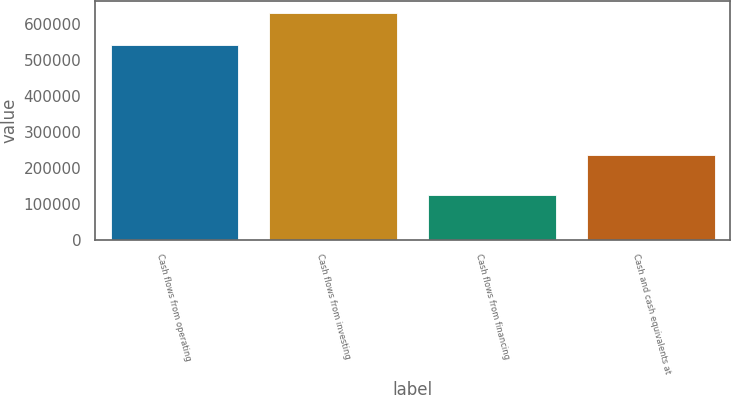Convert chart. <chart><loc_0><loc_0><loc_500><loc_500><bar_chart><fcel>Cash flows from operating<fcel>Cash flows from investing<fcel>Cash flows from financing<fcel>Cash and cash equivalents at<nl><fcel>541216<fcel>632703<fcel>125373<fcel>236484<nl></chart> 